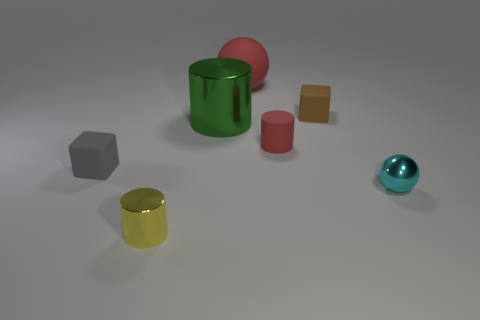Subtract all tiny cylinders. How many cylinders are left? 1 Subtract 1 blocks. How many blocks are left? 1 Add 2 yellow metal things. How many objects exist? 9 Subtract all spheres. How many objects are left? 5 Subtract all yellow balls. How many green cylinders are left? 1 Subtract all red rubber things. Subtract all large green metallic cylinders. How many objects are left? 4 Add 3 green metal cylinders. How many green metal cylinders are left? 4 Add 1 red cylinders. How many red cylinders exist? 2 Subtract all green cylinders. How many cylinders are left? 2 Subtract 0 brown cylinders. How many objects are left? 7 